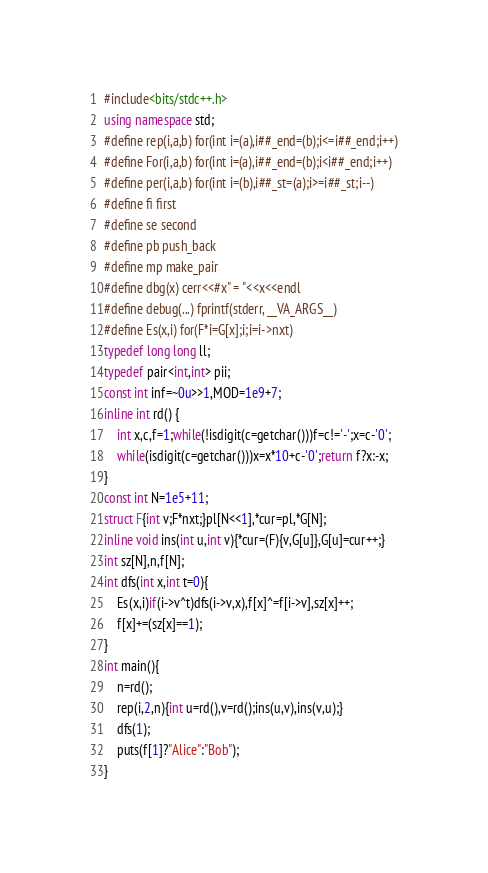Convert code to text. <code><loc_0><loc_0><loc_500><loc_500><_C++_>#include<bits/stdc++.h>
using namespace std;
#define rep(i,a,b) for(int i=(a),i##_end=(b);i<=i##_end;i++)
#define For(i,a,b) for(int i=(a),i##_end=(b);i<i##_end;i++)
#define per(i,a,b) for(int i=(b),i##_st=(a);i>=i##_st;i--)
#define fi first
#define se second
#define pb push_back
#define mp make_pair
#define dbg(x) cerr<<#x" = "<<x<<endl
#define debug(...) fprintf(stderr, __VA_ARGS__)
#define Es(x,i) for(F*i=G[x];i;i=i->nxt)
typedef long long ll;
typedef pair<int,int> pii;
const int inf=~0u>>1,MOD=1e9+7;
inline int rd() {
    int x,c,f=1;while(!isdigit(c=getchar()))f=c!='-';x=c-'0';
    while(isdigit(c=getchar()))x=x*10+c-'0';return f?x:-x;
}
const int N=1e5+11;
struct F{int v;F*nxt;}pl[N<<1],*cur=pl,*G[N];
inline void ins(int u,int v){*cur=(F){v,G[u]},G[u]=cur++;}
int sz[N],n,f[N];
int dfs(int x,int t=0){
	Es(x,i)if(i->v^t)dfs(i->v,x),f[x]^=f[i->v],sz[x]++;
	f[x]+=(sz[x]==1);
}
int main(){
	n=rd();
	rep(i,2,n){int u=rd(),v=rd();ins(u,v),ins(v,u);}
	dfs(1);
	puts(f[1]?"Alice":"Bob");
}</code> 